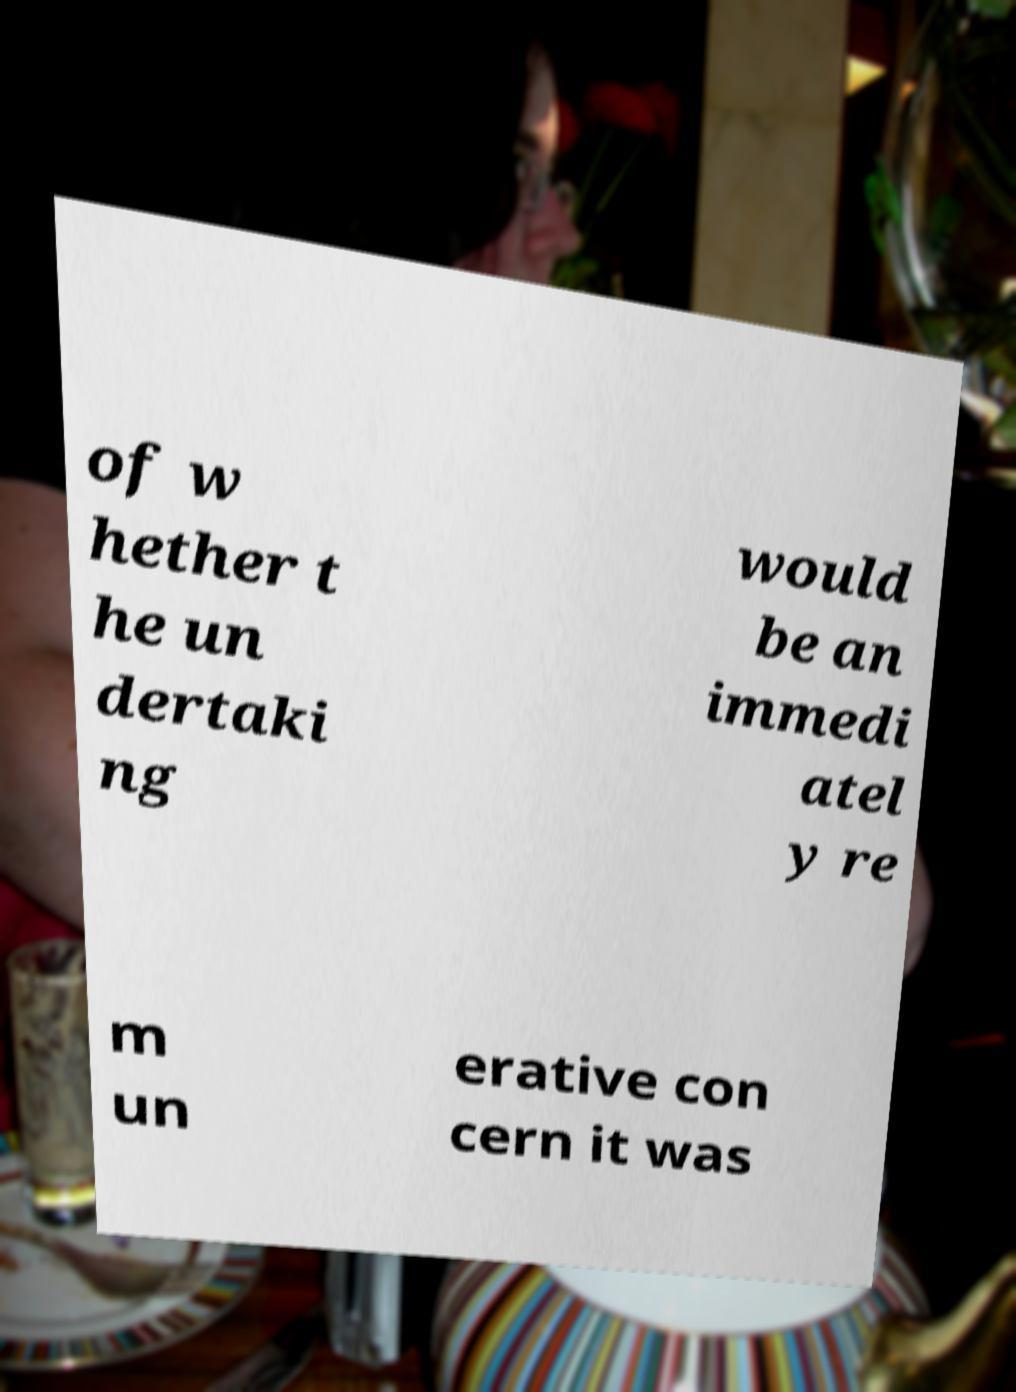What messages or text are displayed in this image? I need them in a readable, typed format. of w hether t he un dertaki ng would be an immedi atel y re m un erative con cern it was 